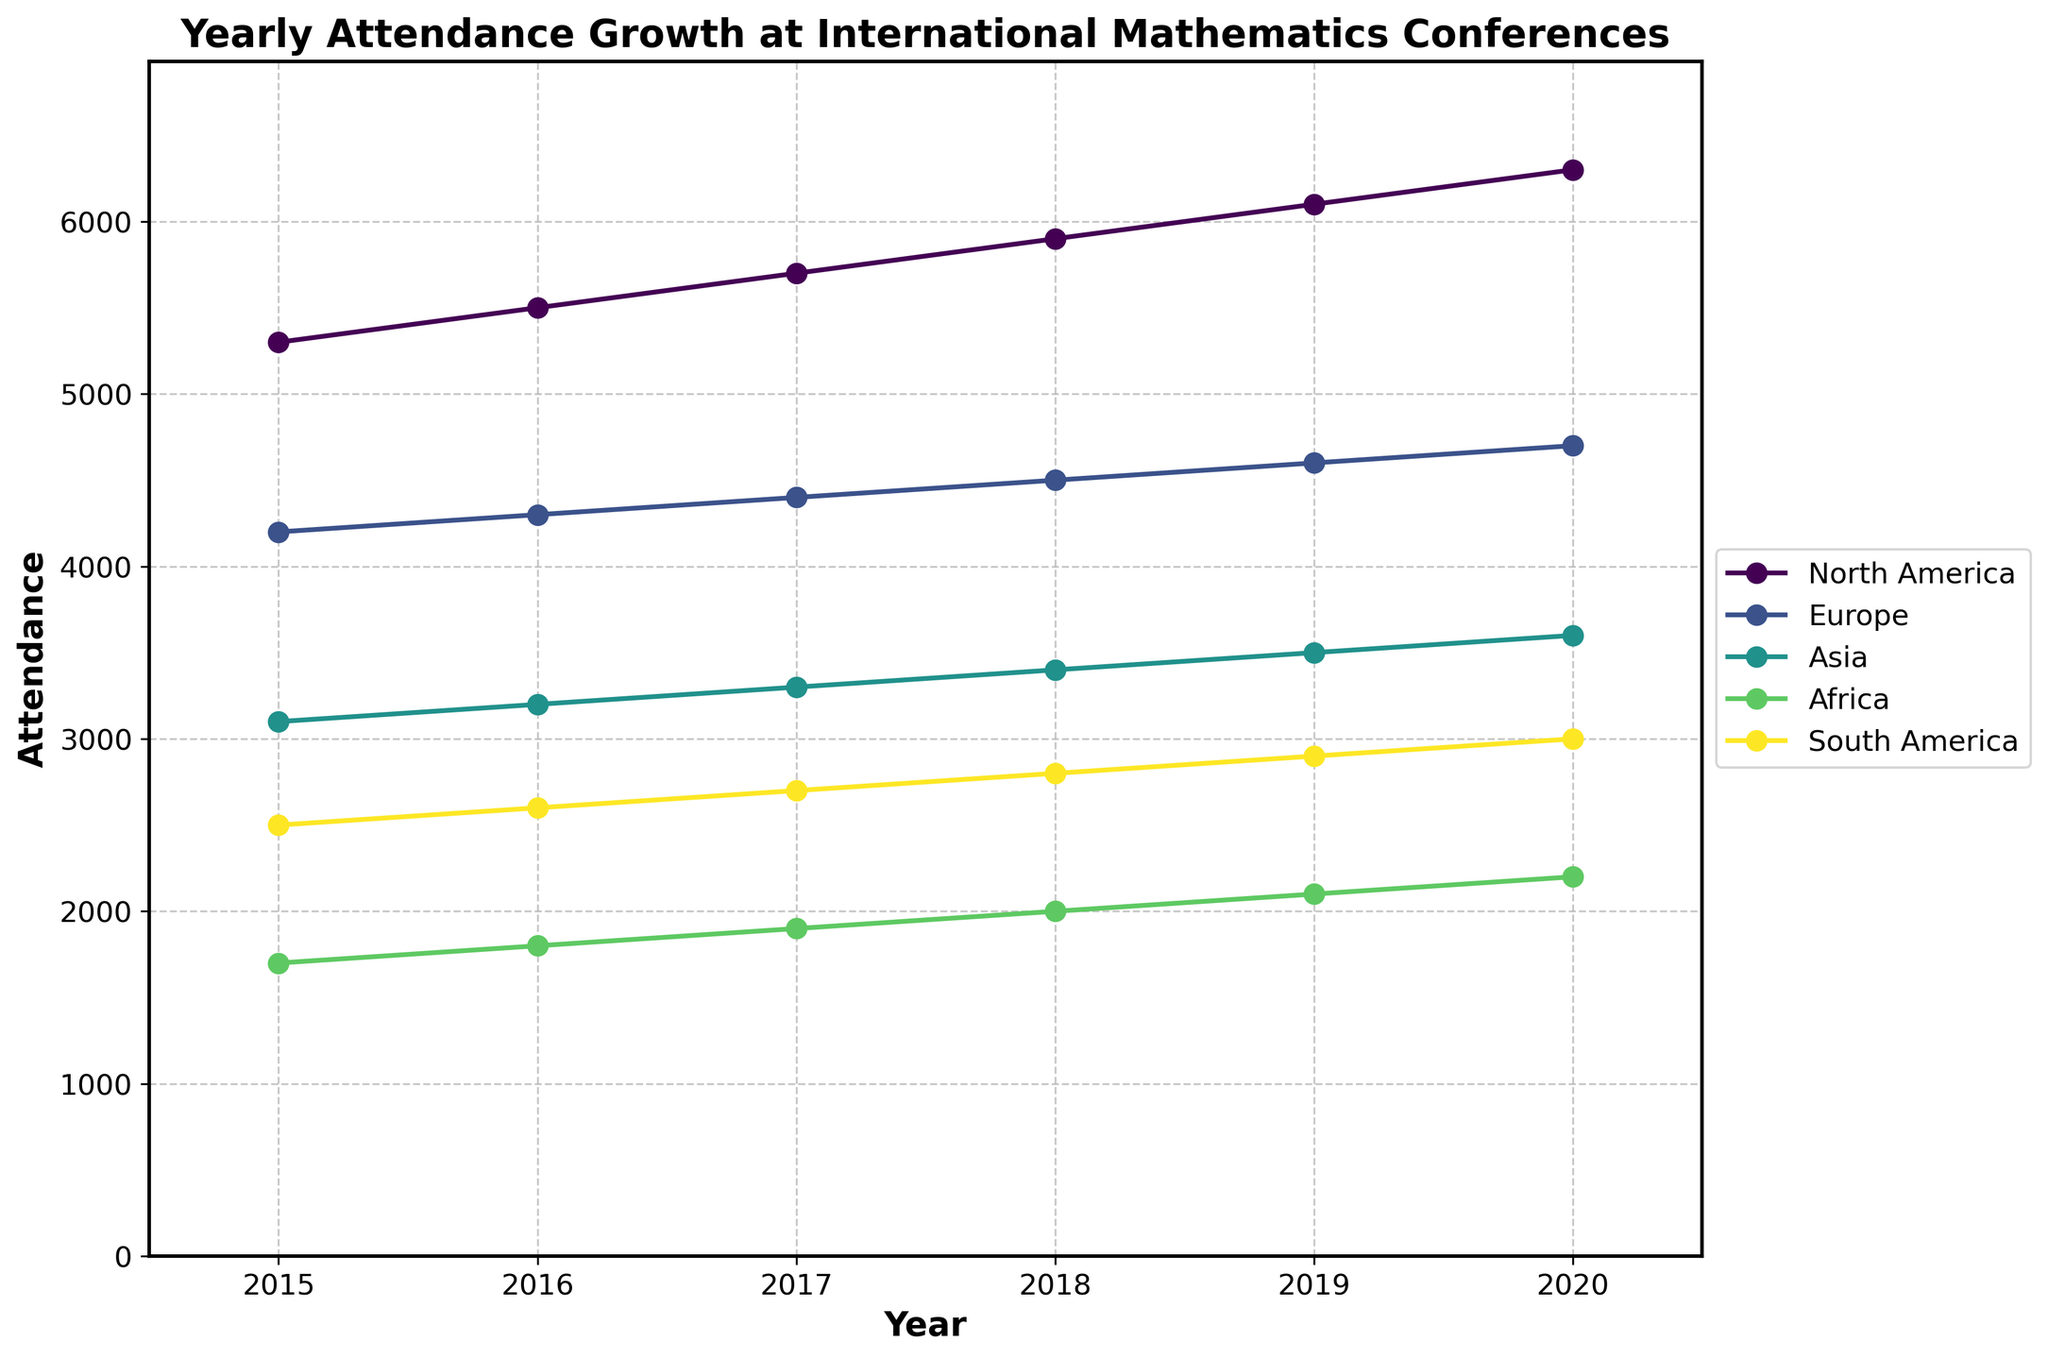What is the title of the figure? To find the title, look at the top of the plot where the title is usually located. It reads, 'Yearly Attendance Growth at International Mathematics Conferences'.
Answer: Yearly Attendance Growth at International Mathematics Conferences What is the highest attendance recorded in any year, and which conference does it correspond to? Look at the highest point on the y-axis and find the data point it corresponds to. The highest value is 6300 in 2020, corresponding to the Joint Mathematics Meetings in North America.
Answer: Joint Mathematics Meetings, North America, 6300 How does the attendance of the European Congress of Mathematics change from 2015 to 2020? Identify the points for the European Congress of Mathematics and plot them over the specified years: the values are 4200 (2015), 4300 (2016), 4400 (2017), 4500 (2018), 4600 (2019), and 4700 (2020). The trend shows an incremental increase each year.
Answer: Increases from 4200 to 4700 Which continent shows the steepest increase in attendance over the years? To determine this, compare the slopes of the attendance lines for each continent. North America has the steepest increase, as the attendance rises from 5300 (2015) to 6300 (2020), a rise of 1000.
Answer: North America By how much did the attendance for the Asian Mathematical Conference increase from 2018 to 2020? Look at the attendance values for 2018 (3400) and 2020 (3600). The increase is 3600 - 3400 = 200.
Answer: 200 Which continent had the lowest attendance in 2015? Identify the data point for each continent in 2015 and find the smallest value. The lowest is 1700, corresponding to Africa.
Answer: Africa Compare the attendance growth rate of the Panafrican Congress of Mathematicians to that of the Latin American Congress of Mathematicians from 2015 to 2020. Calculate the growth for both: Africa starts at 1700 (2015) and ends at 2200 (2020), an increase of 500. South America starts at 2500 (2015) and ends at 3000 (2020), also an increase of 500. The growth rates are identical.
Answer: Identical growth rates What trend do you notice in the attendance numbers across all continents from 2015 to 2020? Observing the general direction of the lines for each continent from left (2015) to right (2020), each shows an increasing trend, indicating a consistent rise in attendance.
Answer: Increasing Which year had the smallest increase in attendance for Asia compared to the previous year? Look at the year-over-year increases for Asia: 2015 (3100), 2016 (3200), 2017 (3300), 2018 (3400), 2019 (3500), and 2020 (3600). The smallest increase is from 2015 to 2016 (3100 to 3200), an increase of 100.
Answer: 2015 to 2016 